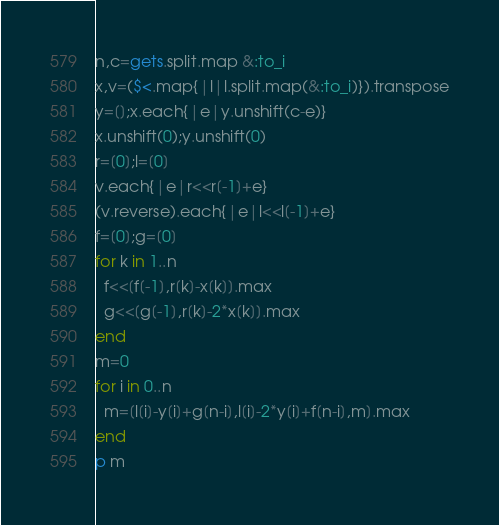<code> <loc_0><loc_0><loc_500><loc_500><_Ruby_>n,c=gets.split.map &:to_i
x,v=($<.map{|l|l.split.map(&:to_i)}).transpose
y=[];x.each{|e|y.unshift(c-e)}
x.unshift(0);y.unshift(0)
r=[0];l=[0]
v.each{|e|r<<r[-1]+e}
(v.reverse).each{|e|l<<l[-1]+e}
f=[0];g=[0]
for k in 1..n
  f<<[f[-1],r[k]-x[k]].max
  g<<[g[-1],r[k]-2*x[k]].max
end
m=0
for i in 0..n
  m=[l[i]-y[i]+g[n-i],l[i]-2*y[i]+f[n-i],m].max
end
p m</code> 